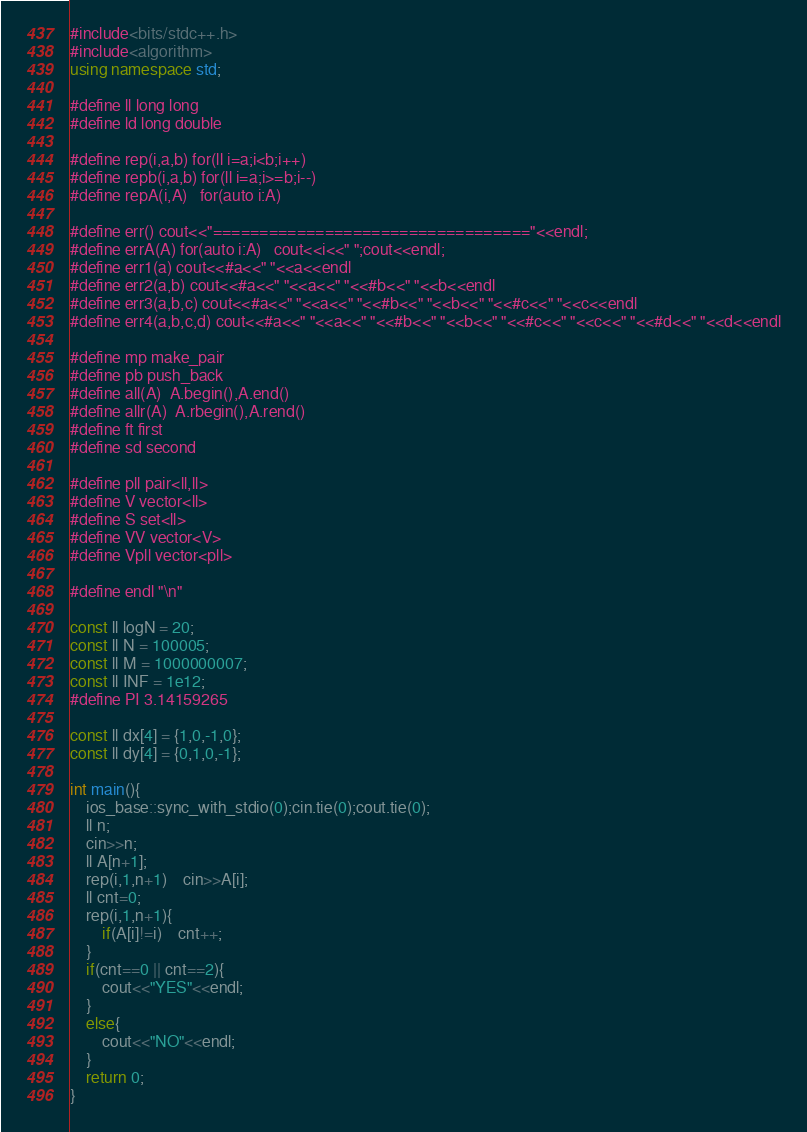Convert code to text. <code><loc_0><loc_0><loc_500><loc_500><_C++_>#include<bits/stdc++.h>
#include<algorithm>
using namespace std;

#define ll long long
#define ld long double

#define rep(i,a,b) for(ll i=a;i<b;i++)
#define repb(i,a,b) for(ll i=a;i>=b;i--)
#define repA(i,A)   for(auto i:A)

#define err() cout<<"=================================="<<endl;
#define errA(A) for(auto i:A)   cout<<i<<" ";cout<<endl;
#define err1(a) cout<<#a<<" "<<a<<endl
#define err2(a,b) cout<<#a<<" "<<a<<" "<<#b<<" "<<b<<endl
#define err3(a,b,c) cout<<#a<<" "<<a<<" "<<#b<<" "<<b<<" "<<#c<<" "<<c<<endl
#define err4(a,b,c,d) cout<<#a<<" "<<a<<" "<<#b<<" "<<b<<" "<<#c<<" "<<c<<" "<<#d<<" "<<d<<endl

#define mp make_pair
#define pb push_back
#define all(A)  A.begin(),A.end()
#define allr(A)	A.rbegin(),A.rend()
#define ft first
#define sd second

#define pll pair<ll,ll>
#define V vector<ll>
#define S set<ll>
#define VV vector<V> 
#define Vpll vector<pll>

#define endl "\n"

const ll logN = 20;
const ll N = 100005;
const ll M = 1000000007;
const ll INF = 1e12;
#define PI 3.14159265

const ll dx[4] = {1,0,-1,0};
const ll dy[4] = {0,1,0,-1};

int main(){
    ios_base::sync_with_stdio(0);cin.tie(0);cout.tie(0);
    ll n;
    cin>>n;
    ll A[n+1];
    rep(i,1,n+1)	cin>>A[i];
    ll cnt=0;
    rep(i,1,n+1){
    	if(A[i]!=i)	cnt++;
    }	
    if(cnt==0 || cnt==2){
    	cout<<"YES"<<endl;
    }
    else{
    	cout<<"NO"<<endl;
    }
    return 0;
}</code> 